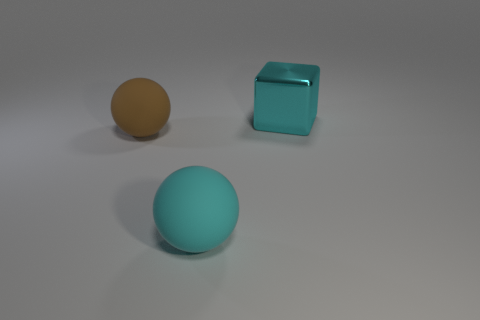Add 3 cyan metal things. How many objects exist? 6 Subtract all blocks. How many objects are left? 2 Subtract 0 red spheres. How many objects are left? 3 Subtract all large green metallic objects. Subtract all balls. How many objects are left? 1 Add 2 big metal things. How many big metal things are left? 3 Add 2 big cyan objects. How many big cyan objects exist? 4 